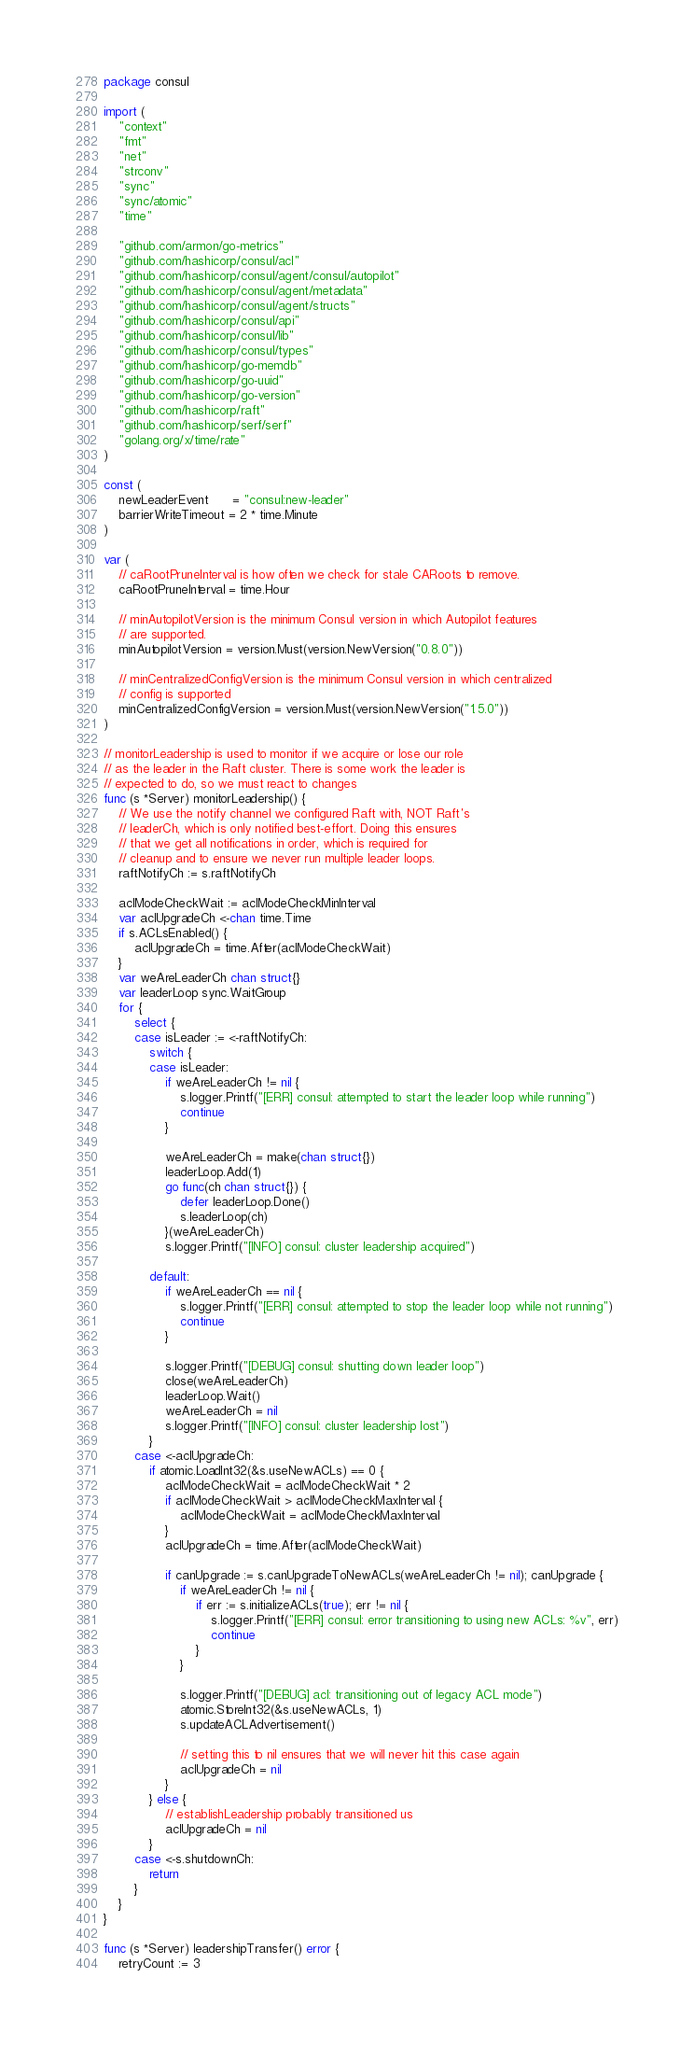Convert code to text. <code><loc_0><loc_0><loc_500><loc_500><_Go_>package consul

import (
	"context"
	"fmt"
	"net"
	"strconv"
	"sync"
	"sync/atomic"
	"time"

	"github.com/armon/go-metrics"
	"github.com/hashicorp/consul/acl"
	"github.com/hashicorp/consul/agent/consul/autopilot"
	"github.com/hashicorp/consul/agent/metadata"
	"github.com/hashicorp/consul/agent/structs"
	"github.com/hashicorp/consul/api"
	"github.com/hashicorp/consul/lib"
	"github.com/hashicorp/consul/types"
	"github.com/hashicorp/go-memdb"
	"github.com/hashicorp/go-uuid"
	"github.com/hashicorp/go-version"
	"github.com/hashicorp/raft"
	"github.com/hashicorp/serf/serf"
	"golang.org/x/time/rate"
)

const (
	newLeaderEvent      = "consul:new-leader"
	barrierWriteTimeout = 2 * time.Minute
)

var (
	// caRootPruneInterval is how often we check for stale CARoots to remove.
	caRootPruneInterval = time.Hour

	// minAutopilotVersion is the minimum Consul version in which Autopilot features
	// are supported.
	minAutopilotVersion = version.Must(version.NewVersion("0.8.0"))

	// minCentralizedConfigVersion is the minimum Consul version in which centralized
	// config is supported
	minCentralizedConfigVersion = version.Must(version.NewVersion("1.5.0"))
)

// monitorLeadership is used to monitor if we acquire or lose our role
// as the leader in the Raft cluster. There is some work the leader is
// expected to do, so we must react to changes
func (s *Server) monitorLeadership() {
	// We use the notify channel we configured Raft with, NOT Raft's
	// leaderCh, which is only notified best-effort. Doing this ensures
	// that we get all notifications in order, which is required for
	// cleanup and to ensure we never run multiple leader loops.
	raftNotifyCh := s.raftNotifyCh

	aclModeCheckWait := aclModeCheckMinInterval
	var aclUpgradeCh <-chan time.Time
	if s.ACLsEnabled() {
		aclUpgradeCh = time.After(aclModeCheckWait)
	}
	var weAreLeaderCh chan struct{}
	var leaderLoop sync.WaitGroup
	for {
		select {
		case isLeader := <-raftNotifyCh:
			switch {
			case isLeader:
				if weAreLeaderCh != nil {
					s.logger.Printf("[ERR] consul: attempted to start the leader loop while running")
					continue
				}

				weAreLeaderCh = make(chan struct{})
				leaderLoop.Add(1)
				go func(ch chan struct{}) {
					defer leaderLoop.Done()
					s.leaderLoop(ch)
				}(weAreLeaderCh)
				s.logger.Printf("[INFO] consul: cluster leadership acquired")

			default:
				if weAreLeaderCh == nil {
					s.logger.Printf("[ERR] consul: attempted to stop the leader loop while not running")
					continue
				}

				s.logger.Printf("[DEBUG] consul: shutting down leader loop")
				close(weAreLeaderCh)
				leaderLoop.Wait()
				weAreLeaderCh = nil
				s.logger.Printf("[INFO] consul: cluster leadership lost")
			}
		case <-aclUpgradeCh:
			if atomic.LoadInt32(&s.useNewACLs) == 0 {
				aclModeCheckWait = aclModeCheckWait * 2
				if aclModeCheckWait > aclModeCheckMaxInterval {
					aclModeCheckWait = aclModeCheckMaxInterval
				}
				aclUpgradeCh = time.After(aclModeCheckWait)

				if canUpgrade := s.canUpgradeToNewACLs(weAreLeaderCh != nil); canUpgrade {
					if weAreLeaderCh != nil {
						if err := s.initializeACLs(true); err != nil {
							s.logger.Printf("[ERR] consul: error transitioning to using new ACLs: %v", err)
							continue
						}
					}

					s.logger.Printf("[DEBUG] acl: transitioning out of legacy ACL mode")
					atomic.StoreInt32(&s.useNewACLs, 1)
					s.updateACLAdvertisement()

					// setting this to nil ensures that we will never hit this case again
					aclUpgradeCh = nil
				}
			} else {
				// establishLeadership probably transitioned us
				aclUpgradeCh = nil
			}
		case <-s.shutdownCh:
			return
		}
	}
}

func (s *Server) leadershipTransfer() error {
	retryCount := 3</code> 